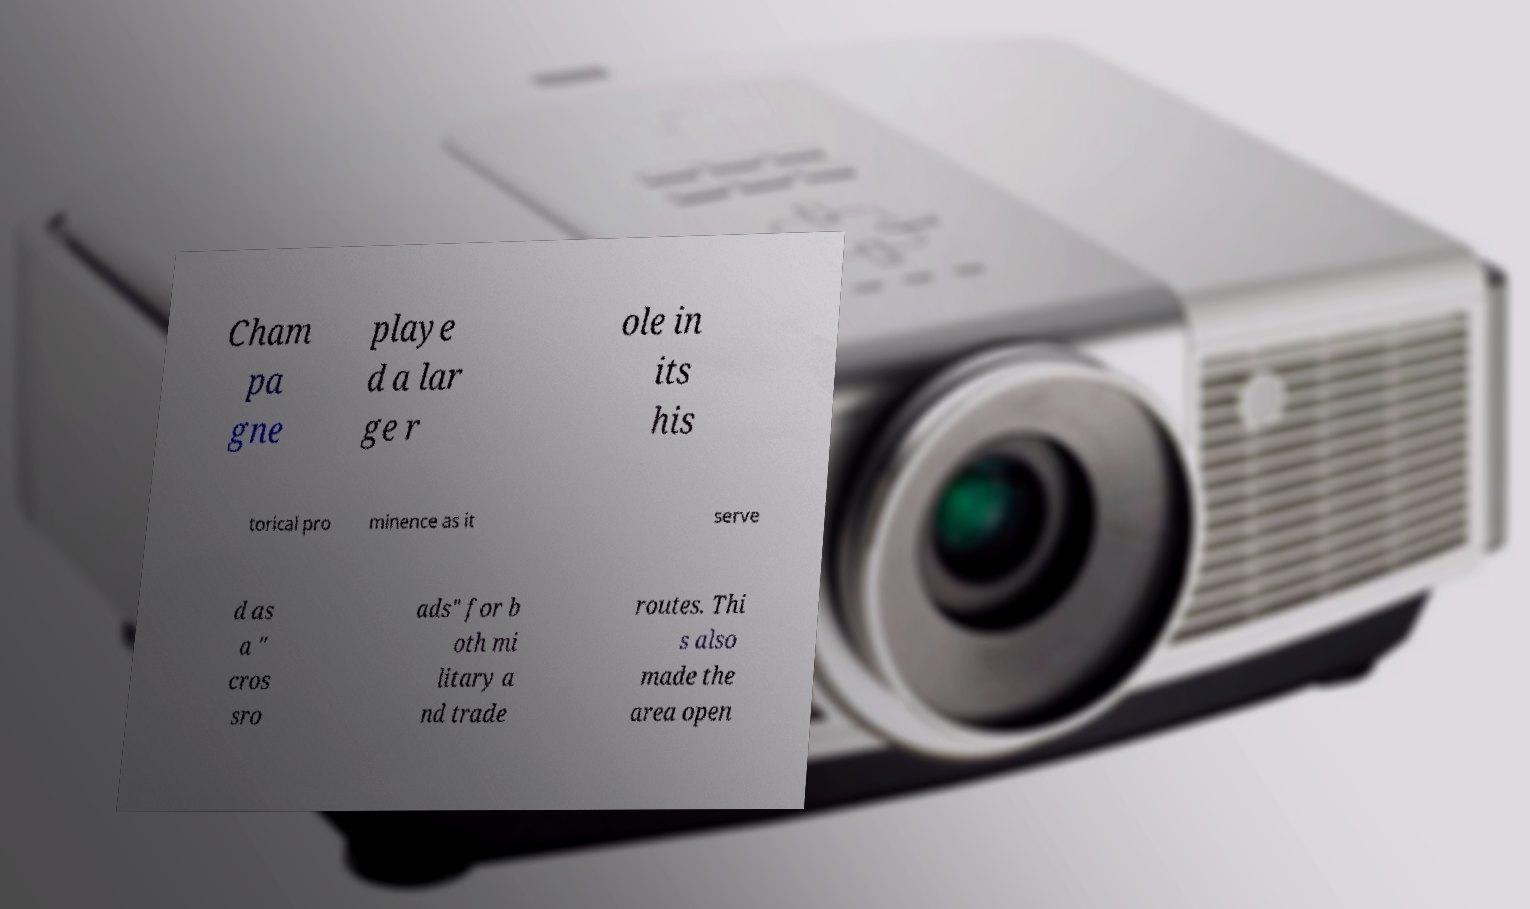What messages or text are displayed in this image? I need them in a readable, typed format. Cham pa gne playe d a lar ge r ole in its his torical pro minence as it serve d as a " cros sro ads" for b oth mi litary a nd trade routes. Thi s also made the area open 